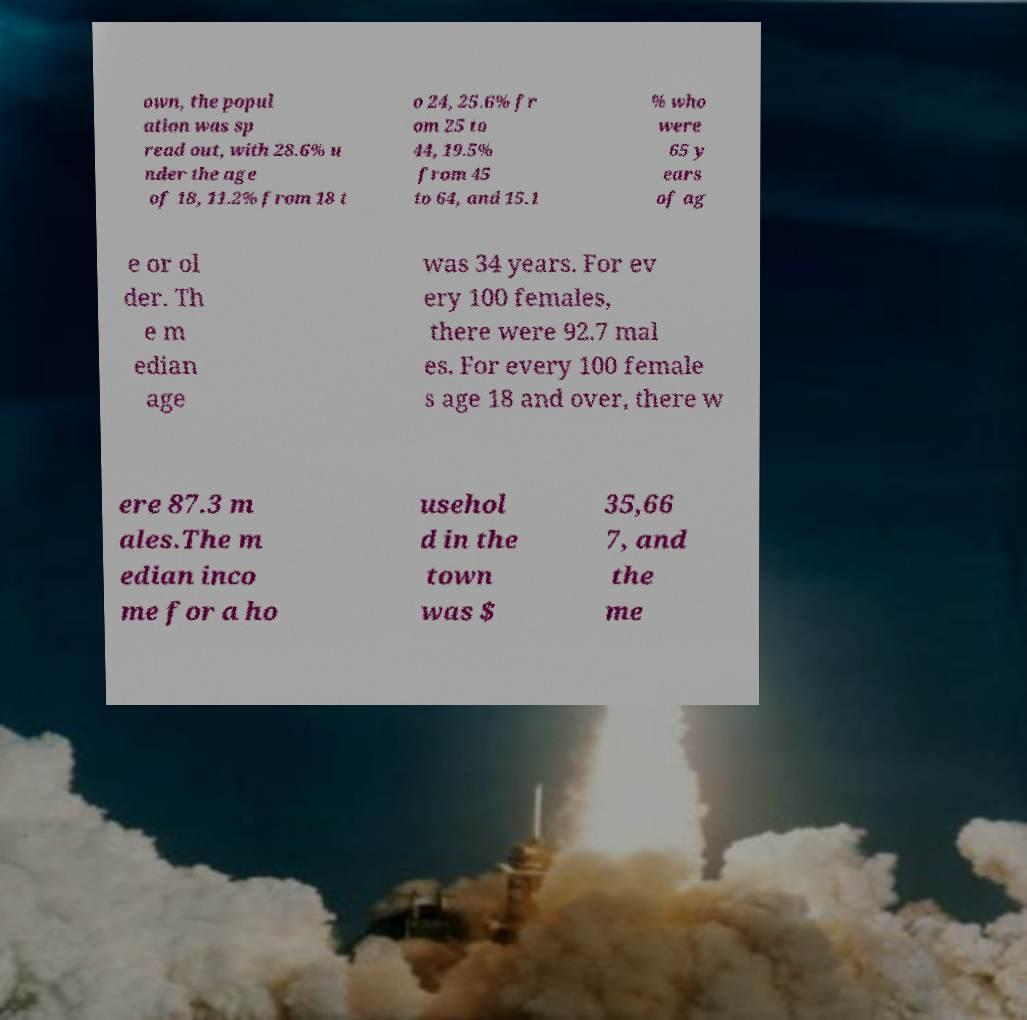Can you accurately transcribe the text from the provided image for me? own, the popul ation was sp read out, with 28.6% u nder the age of 18, 11.2% from 18 t o 24, 25.6% fr om 25 to 44, 19.5% from 45 to 64, and 15.1 % who were 65 y ears of ag e or ol der. Th e m edian age was 34 years. For ev ery 100 females, there were 92.7 mal es. For every 100 female s age 18 and over, there w ere 87.3 m ales.The m edian inco me for a ho usehol d in the town was $ 35,66 7, and the me 